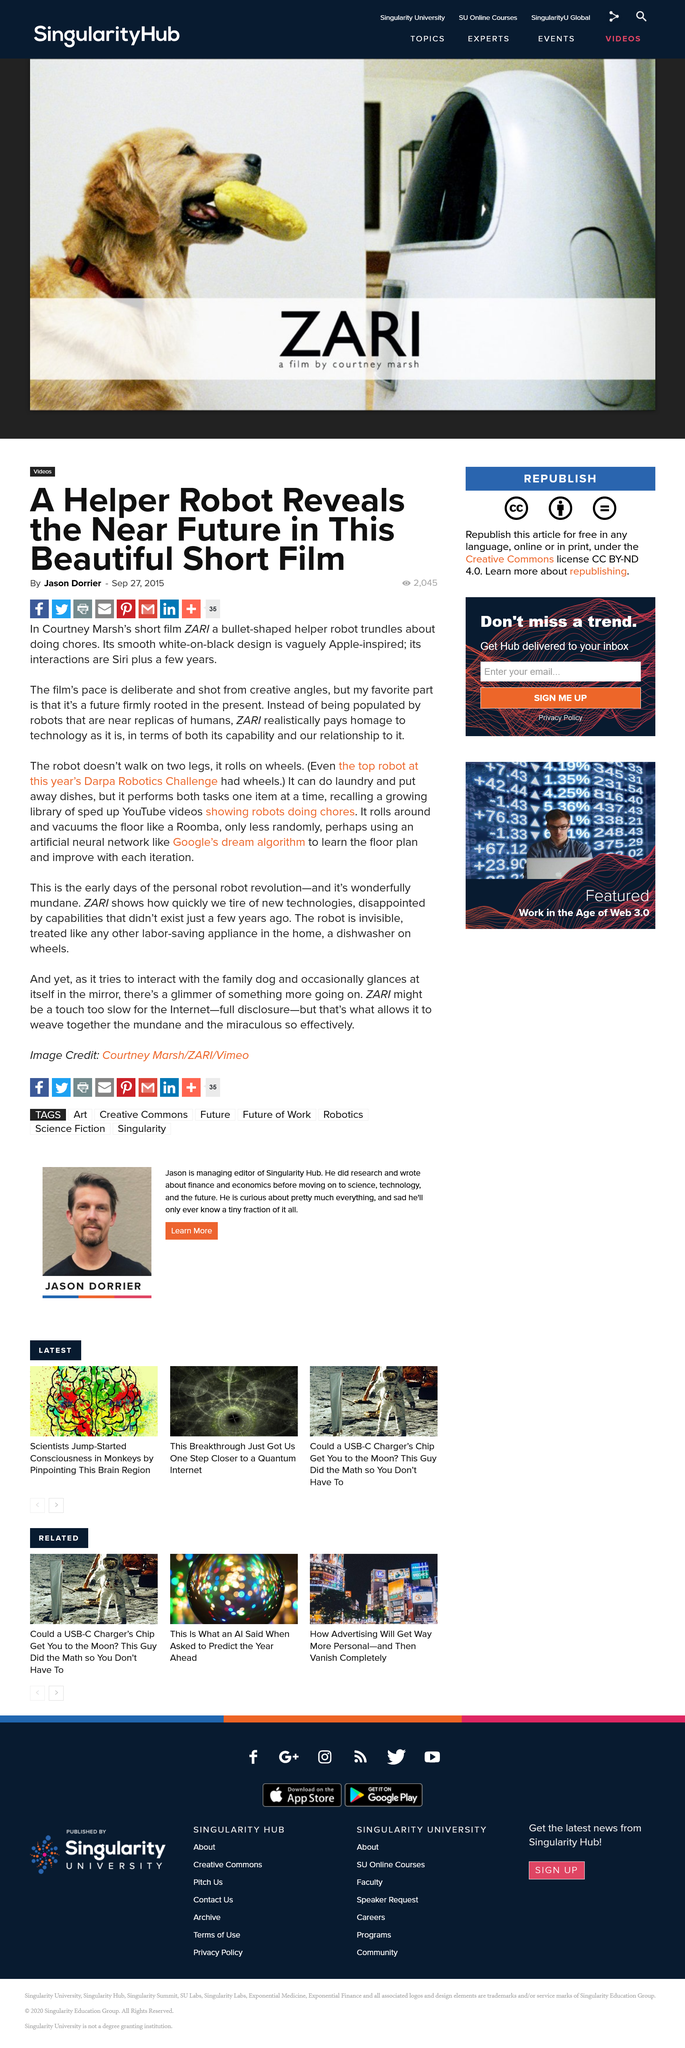Specify some key components in this picture. The helper robot can perform laundry, put away dishes, and vacuum the floor. Jason Dorrier's favorite part of the film ZARI is that it features a future that is firmly rooted in the present. The helper robot described in this article is a bullet-shaped device with a smooth white-on-black design, and it rolls on wheels. 